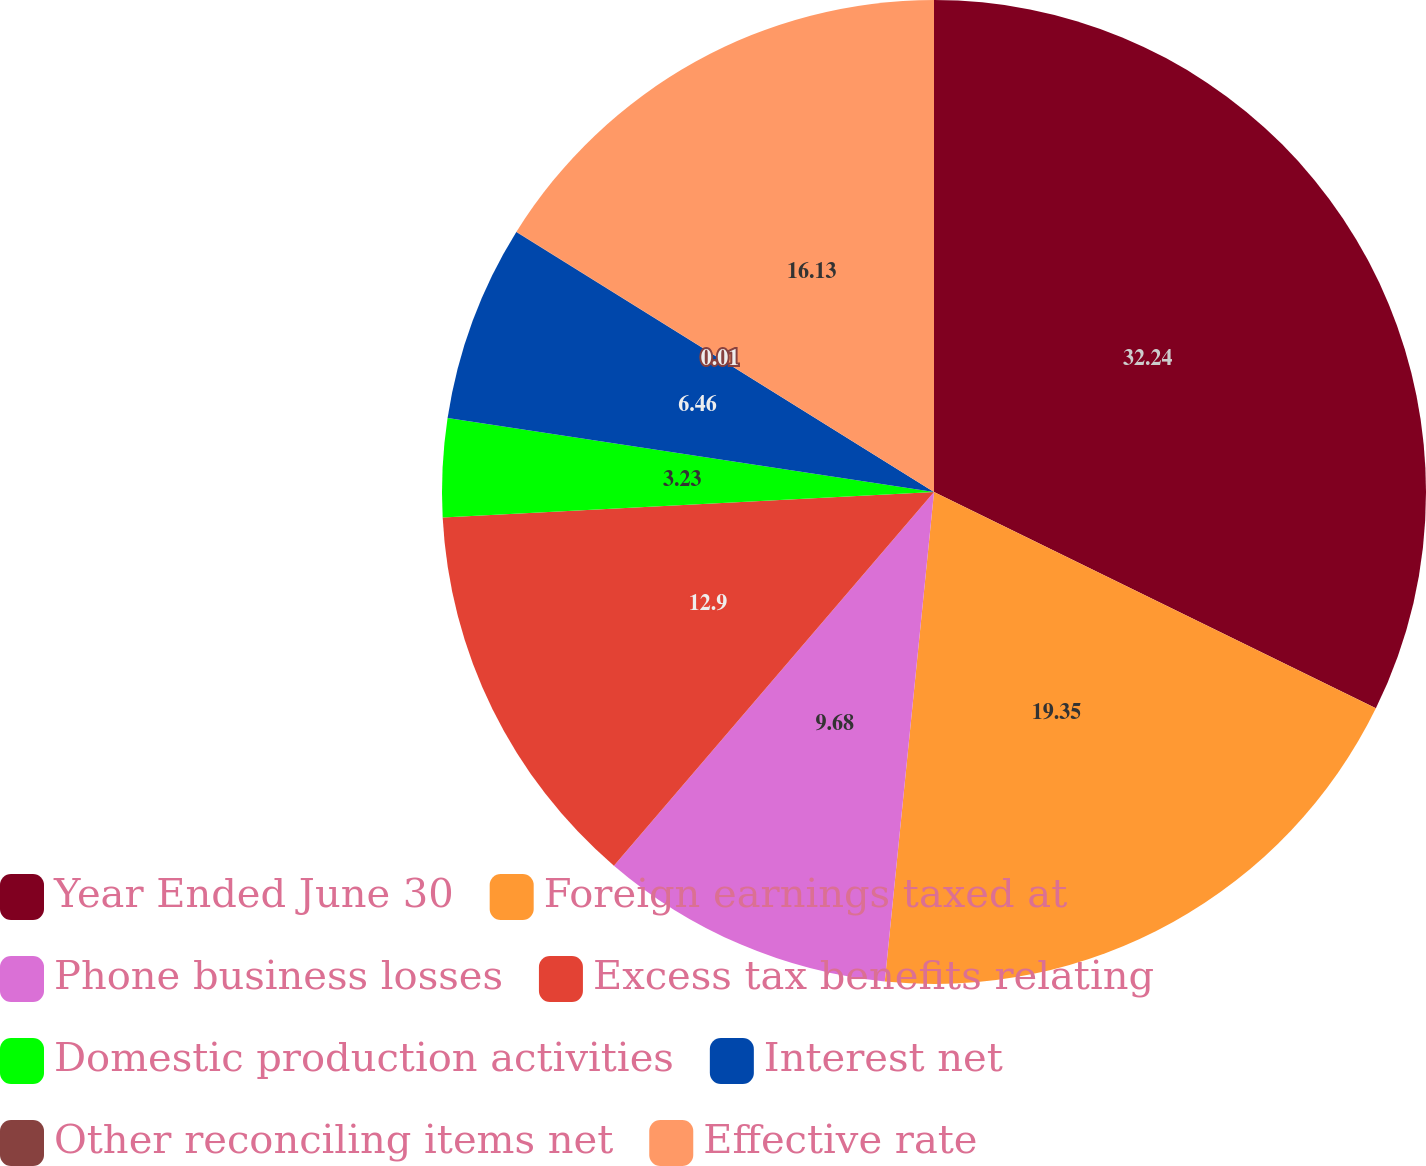Convert chart to OTSL. <chart><loc_0><loc_0><loc_500><loc_500><pie_chart><fcel>Year Ended June 30<fcel>Foreign earnings taxed at<fcel>Phone business losses<fcel>Excess tax benefits relating<fcel>Domestic production activities<fcel>Interest net<fcel>Other reconciling items net<fcel>Effective rate<nl><fcel>32.25%<fcel>19.35%<fcel>9.68%<fcel>12.9%<fcel>3.23%<fcel>6.46%<fcel>0.01%<fcel>16.13%<nl></chart> 